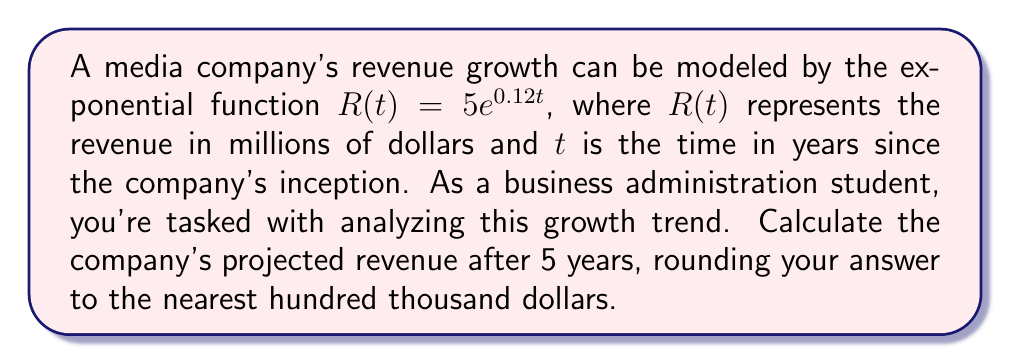Show me your answer to this math problem. To solve this problem, we'll follow these steps:

1) We're given the exponential function: $R(t) = 5e^{0.12t}$

2) We need to find $R(5)$, as we're asked about the revenue after 5 years.

3) Let's substitute $t = 5$ into the equation:

   $R(5) = 5e^{0.12(5)}$

4) Simplify the exponent:
   
   $R(5) = 5e^{0.6}$

5) Now, we need to calculate this value. Let's use a calculator:

   $5e^{0.6} \approx 5 * 1.8221188...$ 
   
   $\approx 9.1105940...$

6) The question asks for the answer in millions of dollars, rounded to the nearest hundred thousand. 
   9.1105940 million is the same as 9,110,594 dollars.

7) Rounding to the nearest hundred thousand gives us 9,100,000 dollars or 9.1 million dollars.
Answer: $9.1$ million dollars 